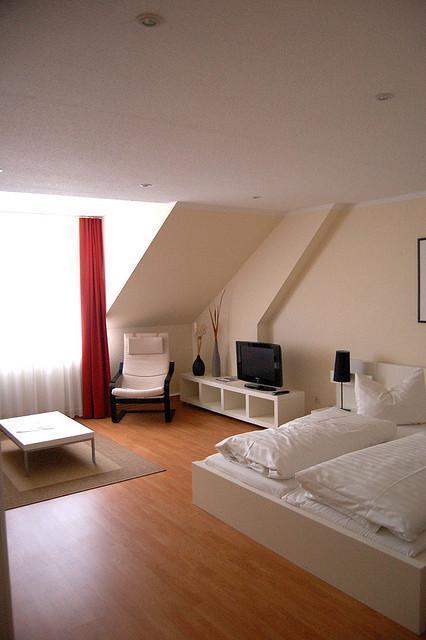How many people can sleep in this room?
Give a very brief answer. 2. 